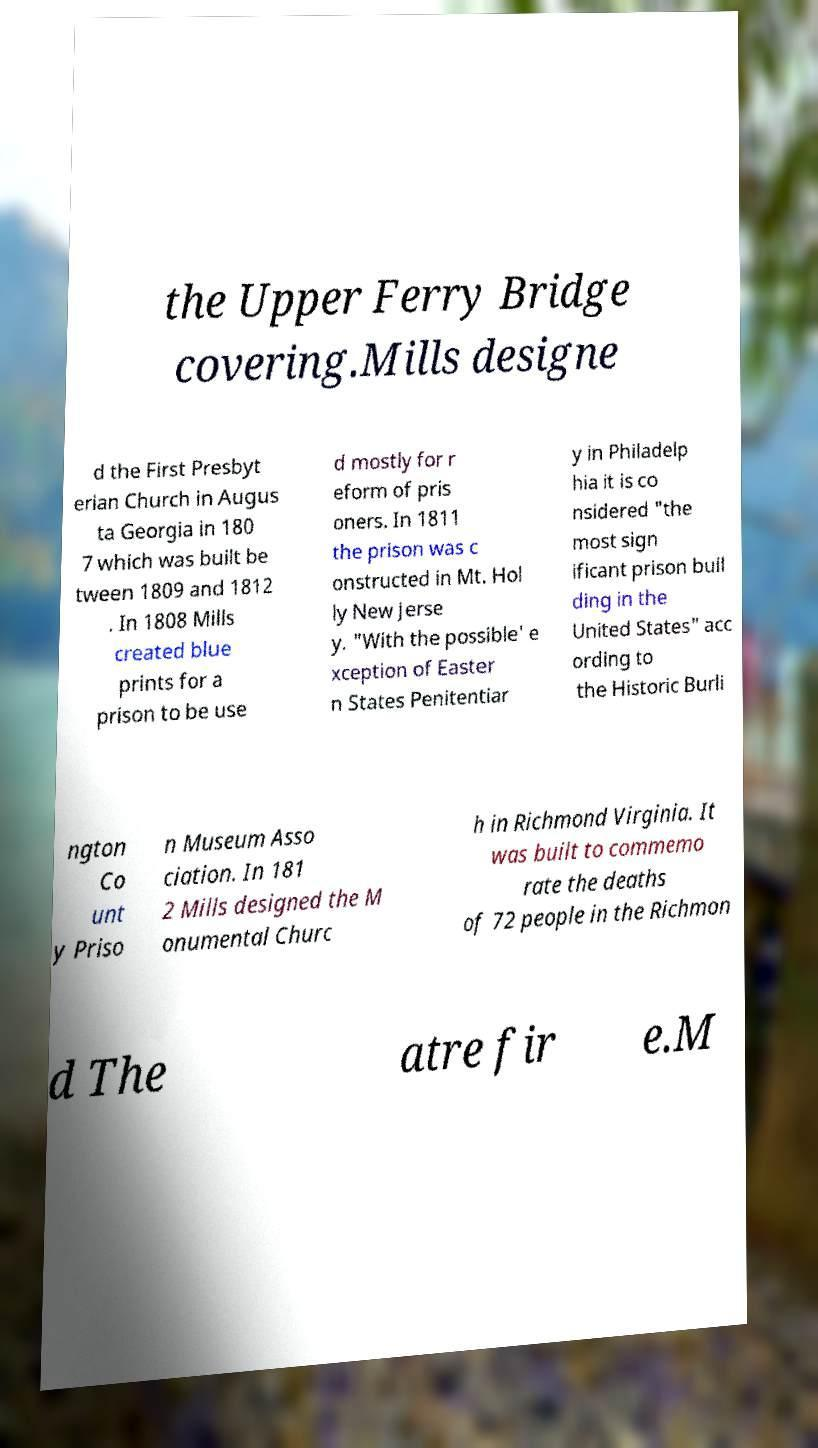There's text embedded in this image that I need extracted. Can you transcribe it verbatim? the Upper Ferry Bridge covering.Mills designe d the First Presbyt erian Church in Augus ta Georgia in 180 7 which was built be tween 1809 and 1812 . In 1808 Mills created blue prints for a prison to be use d mostly for r eform of pris oners. In 1811 the prison was c onstructed in Mt. Hol ly New Jerse y. "With the possible' e xception of Easter n States Penitentiar y in Philadelp hia it is co nsidered "the most sign ificant prison buil ding in the United States" acc ording to the Historic Burli ngton Co unt y Priso n Museum Asso ciation. In 181 2 Mills designed the M onumental Churc h in Richmond Virginia. It was built to commemo rate the deaths of 72 people in the Richmon d The atre fir e.M 